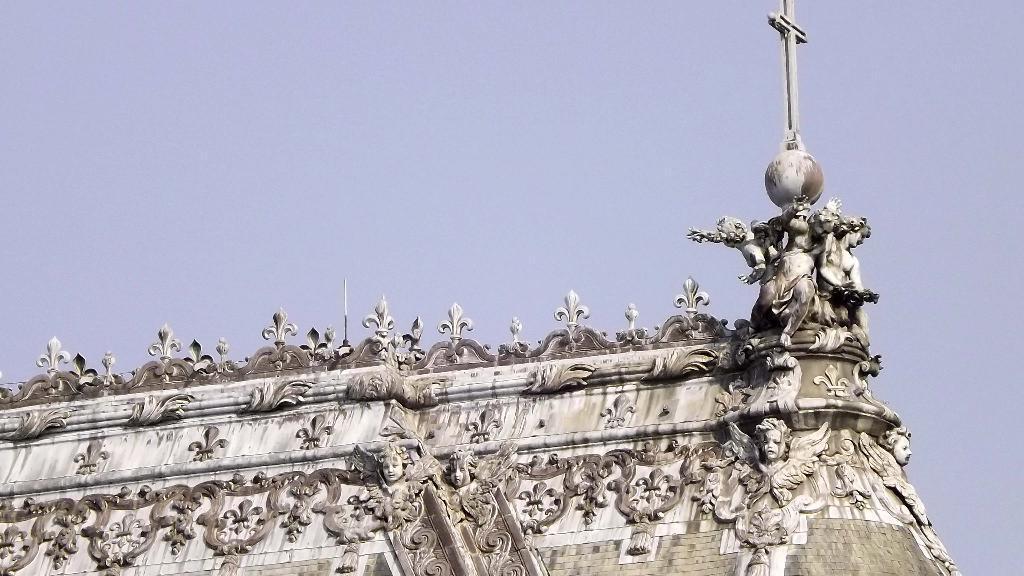Could you give a brief overview of what you see in this image? Here in this picture we can see statues present on a building and we can see some designs also carved over it and at the top of it we can see a Christianity symbol and we can see the sky is cloudy. 